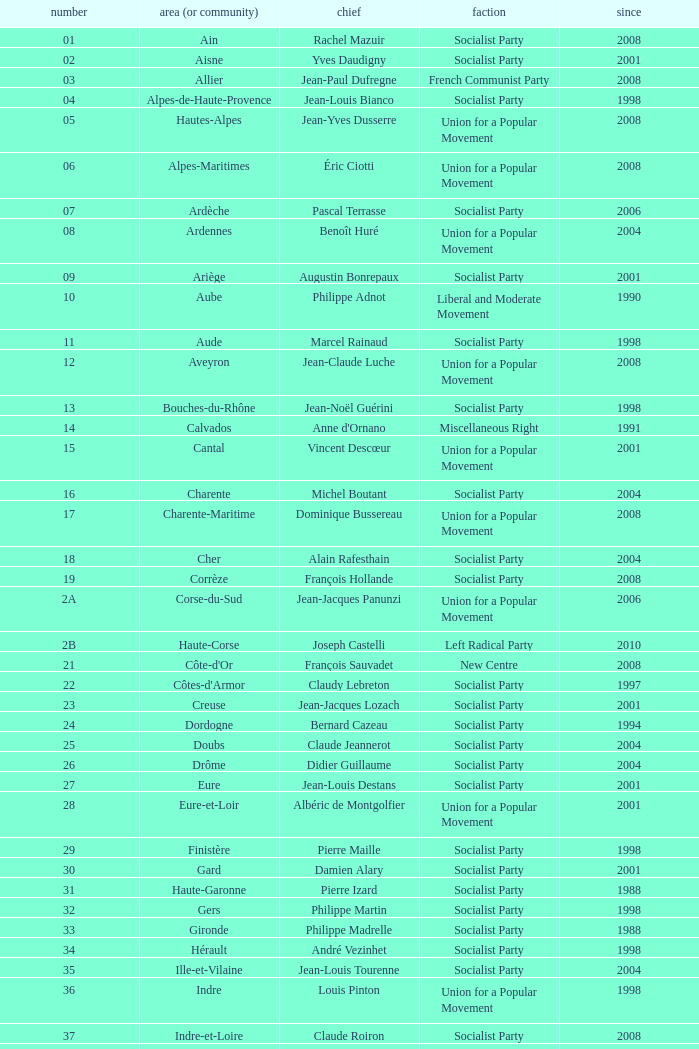Which department has Guy-Dominique Kennel as president since 2008? Bas-Rhin. 